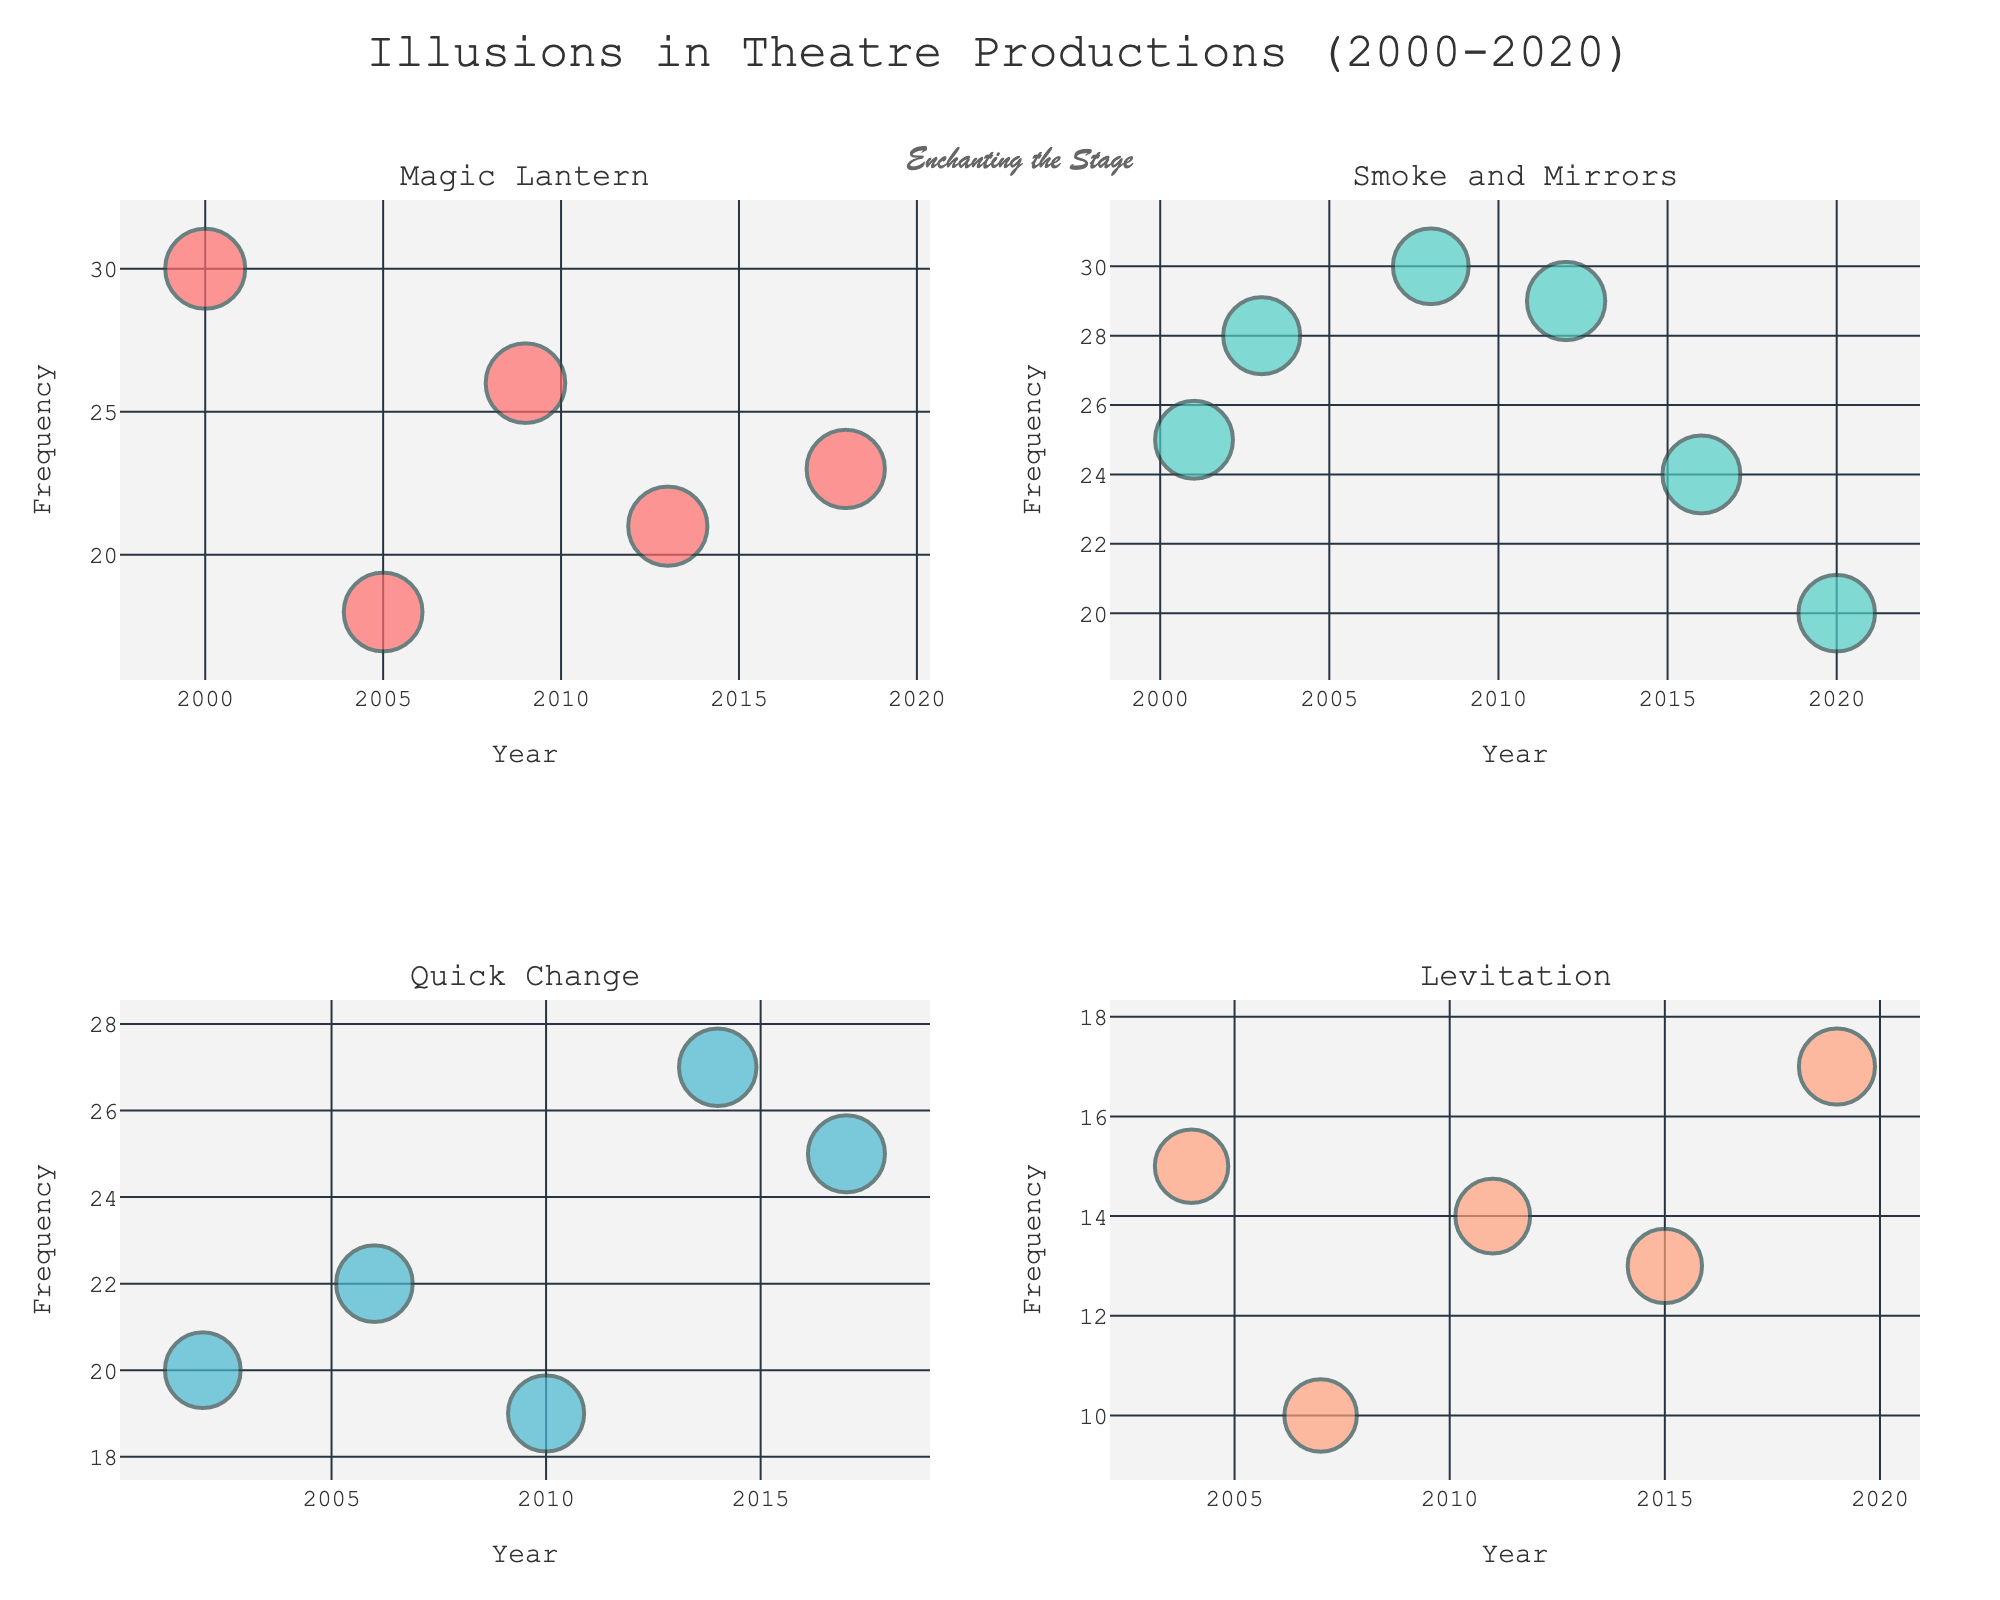What's the title of the subplot figure? The title is displayed at the top center of the figure with a larger font size
Answer: Illusions in Theatre Productions (2000-2020) What illusion type has consistently high frequencies throughout the years shown? Observing the charts, "Smoke and Mirrors" maintains high frequencies in multiple data points over the years
Answer: Smoke and Mirrors Which illusion type has the least number of data points in the figure? Counting the bubbles in each subplot, "Levitation" has the fewest data points
Answer: Levitation Which theatre production used the "Magic Lantern" illusion in 2005? By looking at the "Magic Lantern" subplot and hovering over the year 2005, the theatre production "The Producers" is displayed
Answer: The Producers What is the effectiveness of the "Levitation" illusion used in the production "Aladdin" in 2011? Hover over the data point in the "Levitation" subplot for 2011, the effectiveness is shown in the tooltip
Answer: 83 Compare the frequency of "Quick Change" in the productions of "The Lion King" (2002) and "Wicked" (2010). Which one has a higher frequency? From the "Quick Change" subplot, "The Lion King" in 2002 has a frequency of 20, while "Wicked" in 2010 has a frequency of 19. Therefore, "The Lion King" has a higher frequency
Answer: The Lion King What's the average effectiveness of the "Magic Lantern" illusion over the years displayed? Adding up all the effectiveness values for "Magic Lantern" (95 + 92 + 94 + 93 + 91) and dividing by the number of data points (5), we get an average value
Answer: 93 Which illusion type has the highest effectiveness value and in which production is it used? Checking all four subplots for the maximum effectiveness value, the highest is 95 for the "Magic Lantern" illusion in "Phantom of the Opera" in 2000
Answer: Magic Lantern in Phantom of the Opera Between 2000 and 2020, how many times was "Quick Change" used in theatre productions? Count the number of data points in "Quick Change" subplot, there are 5 points
Answer: 5 Identify the trend in the frequency of "Smoke and Mirrors" illusion from 2001 to 2020. Observing the "Smoke and Mirrors" subplot, the frequencies fluctuate but generally remain high with a peak in 2008
Answer: Fluctuates, generally high 